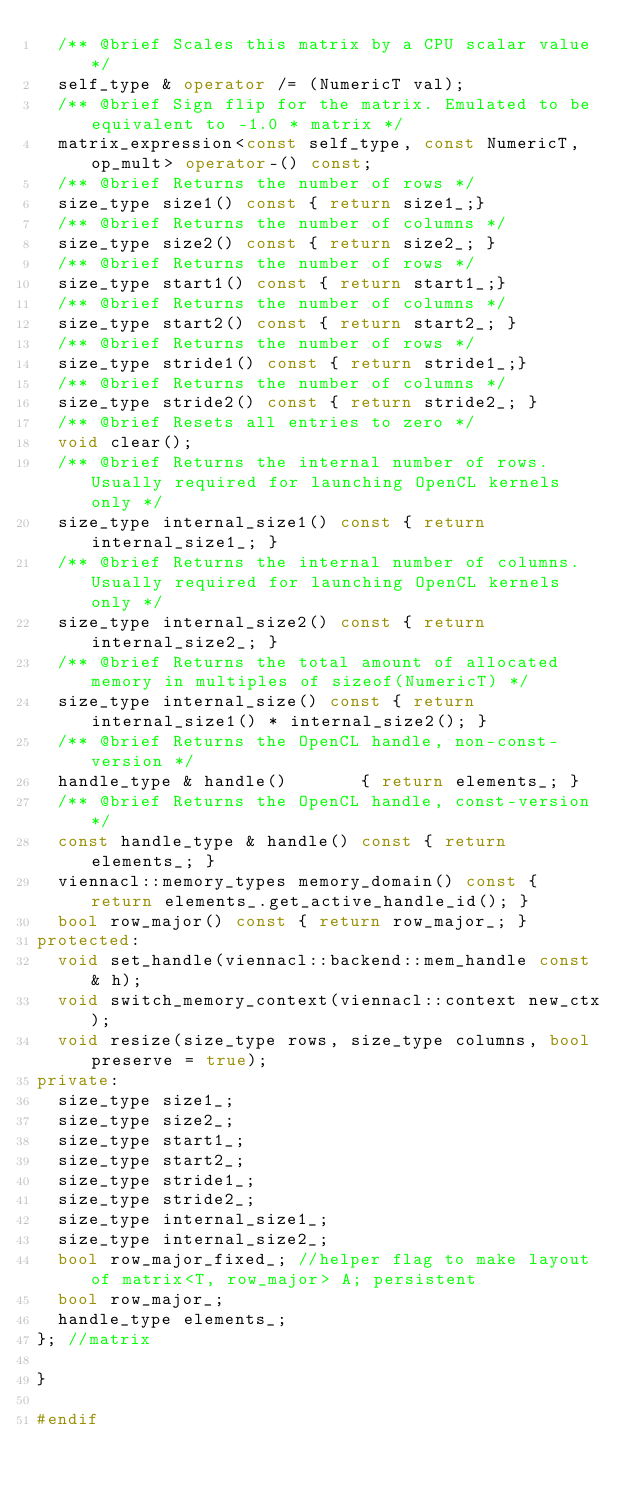<code> <loc_0><loc_0><loc_500><loc_500><_C++_>  /** @brief Scales this matrix by a CPU scalar value */
  self_type & operator /= (NumericT val);
  /** @brief Sign flip for the matrix. Emulated to be equivalent to -1.0 * matrix */
  matrix_expression<const self_type, const NumericT, op_mult> operator-() const;
  /** @brief Returns the number of rows */
  size_type size1() const { return size1_;}
  /** @brief Returns the number of columns */
  size_type size2() const { return size2_; }
  /** @brief Returns the number of rows */
  size_type start1() const { return start1_;}
  /** @brief Returns the number of columns */
  size_type start2() const { return start2_; }
  /** @brief Returns the number of rows */
  size_type stride1() const { return stride1_;}
  /** @brief Returns the number of columns */
  size_type stride2() const { return stride2_; }
  /** @brief Resets all entries to zero */
  void clear();
  /** @brief Returns the internal number of rows. Usually required for launching OpenCL kernels only */
  size_type internal_size1() const { return internal_size1_; }
  /** @brief Returns the internal number of columns. Usually required for launching OpenCL kernels only */
  size_type internal_size2() const { return internal_size2_; }
  /** @brief Returns the total amount of allocated memory in multiples of sizeof(NumericT) */
  size_type internal_size() const { return internal_size1() * internal_size2(); }
  /** @brief Returns the OpenCL handle, non-const-version */
  handle_type & handle()       { return elements_; }
  /** @brief Returns the OpenCL handle, const-version */
  const handle_type & handle() const { return elements_; }
  viennacl::memory_types memory_domain() const { return elements_.get_active_handle_id(); }
  bool row_major() const { return row_major_; }
protected:
  void set_handle(viennacl::backend::mem_handle const & h);
  void switch_memory_context(viennacl::context new_ctx);
  void resize(size_type rows, size_type columns, bool preserve = true);
private:
  size_type size1_;
  size_type size2_;
  size_type start1_;
  size_type start2_;
  size_type stride1_;
  size_type stride2_;
  size_type internal_size1_;
  size_type internal_size2_;
  bool row_major_fixed_; //helper flag to make layout of matrix<T, row_major> A; persistent
  bool row_major_;
  handle_type elements_;
}; //matrix

}

#endif
</code> 